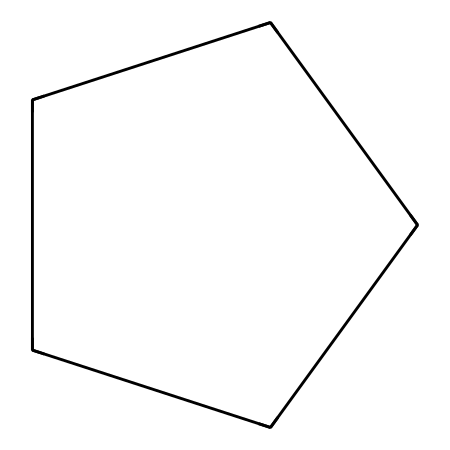What is the name of this chemical? The structure C1CCCC1 corresponds to cyclopentane, which is a cycloalkane with five carbon atoms arranged in a ring.
Answer: cyclopentane How many carbon atoms are in cyclopentane? In the SMILES representation C1CCCC1, the "C" indicates there are five carbon atoms, as they are all bonded in a cyclic structure.
Answer: five What type of bonds are present in cyclopentane? Cyclopentane consists of single covalent bonds (sigma bonds) between the carbon atoms and carbon-hydrogen bonds, which are characteristic of saturated hydrocarbons.
Answer: single bonds What is the molecular formula of cyclopentane? The molecular formula can be derived from the five carbon atoms and ten hydrogen atoms surrounding them in the chemical structure: C5H10.
Answer: C5H10 What is the geometry around each carbon atom in cyclopentane? Each carbon atom in cyclopentane is sp3 hybridized, leading to a tetrahedral geometry with bond angles of about 109.5 degrees, due to the four single bonds formed.
Answer: tetrahedral Does cyclopentane have any degree of strain in its structure? Cyclopentane is generally non-strained and can adopt various conformations, although it is not entirely free of angle strain—considering it has a five-membered ring compared to a six-membered ring which is more stable.
Answer: yes How does cyclopentane compare to other cycloalkanes in terms of ring strain? Cyclopentane has less ring strain than cyclobutane due to more favorable bond angles, but it is more strained than cyclohexane, which has no ring strain, illustrating a continuum of stability among cycloalkanes.
Answer: less strain 